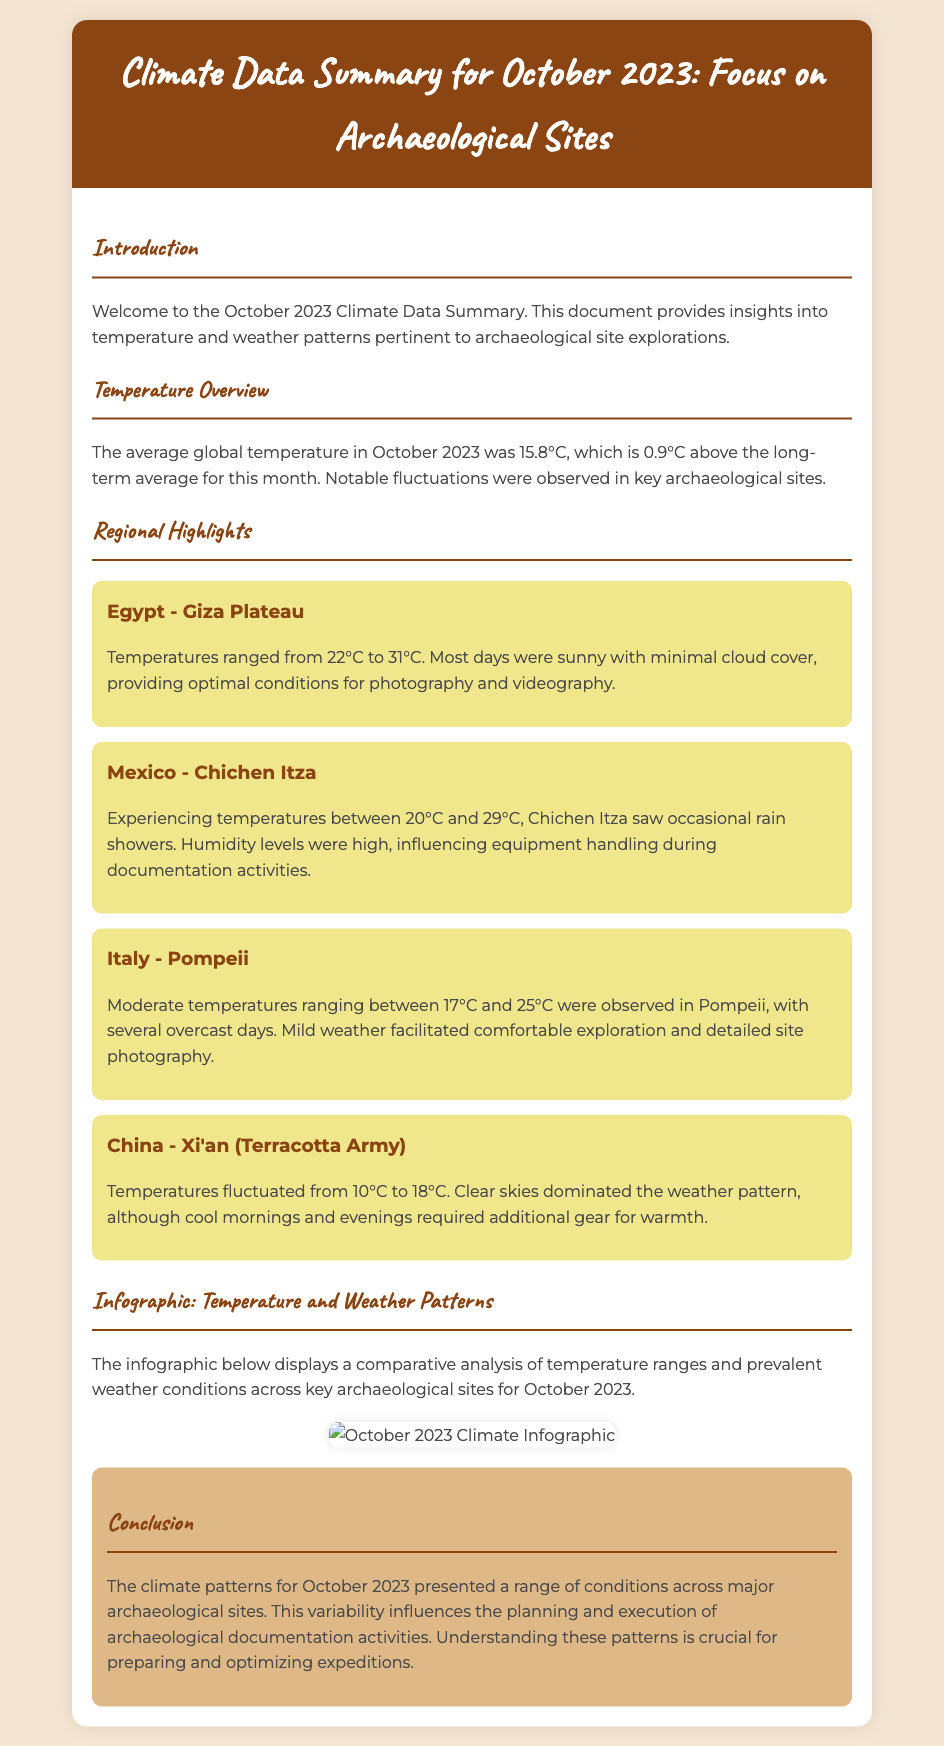what was the average global temperature in October 2023? The average global temperature reported in the document is specifically noted for October 2023 as 15.8°C.
Answer: 15.8°C which archaeological site experienced temperatures between 22°C and 31°C? The document mentions temperature ranges for different sites, indicating that the Giza Plateau in Egypt had temperatures in this range.
Answer: Giza Plateau what was the temperature range in Chichen Itza? The document states that Chichen Itza experienced temperatures between 20°C and 29°C.
Answer: 20°C to 29°C how many regional highlights are discussed in the document? The document lists four regional highlights from various archaeological sites.
Answer: Four what weather pattern was predominant at the Terracotta Army site? The document describes the weather conditions at the Terracotta Army, highlighting that clear skies dominated this region during October 2023.
Answer: Clear skies what type of weather influenced equipment handling in Chichen Itza? The document indicates that occasional rain showers in Chichen Itza influenced equipment handling.
Answer: Occasional rain showers what infographic is included in the document? The document specifies that there is an infographic displaying temperature and weather patterns across key archaeological sites.
Answer: Temperature and weather patterns how did the October climate patterns affect archaeological expeditions? The conclusion states that understanding climate patterns is crucial for preparing and optimizing expeditions, indicating the importance of climate insights in planning.
Answer: Crucial for preparing and optimizing expeditions 